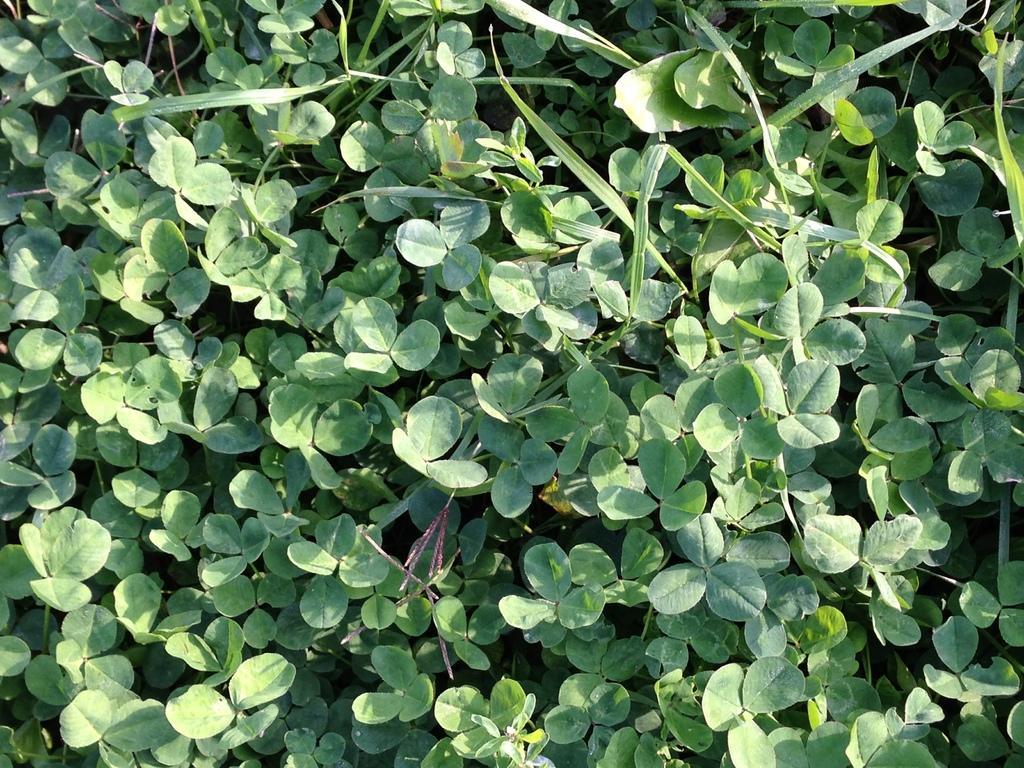Can you describe this image briefly? In this image we can see plants. 